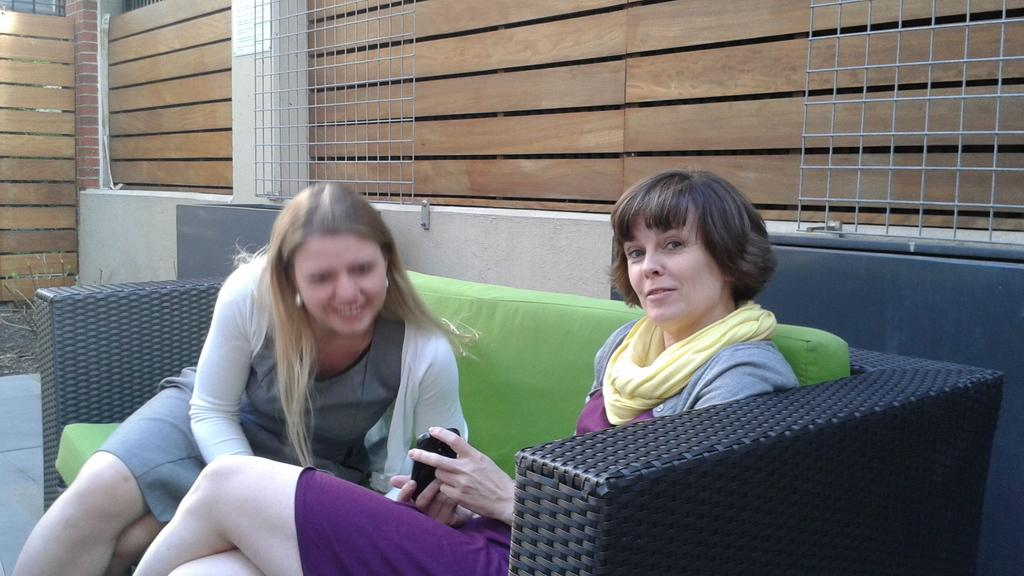How many people are in the image? There are two women in the image. What are the women doing in the image? The women are sitting on a sofa. What is the emotional expression of the women in the image? Both women are smiling. What color is the sofa the women are sitting on? The sofa is black. What type of material can be seen in the background of the image? There is a wooden wall in the background of the image. What type of drum can be seen in the image? There is no drum present in the image. Is there an airplane visible in the image? No, there is no airplane visible in the image. 